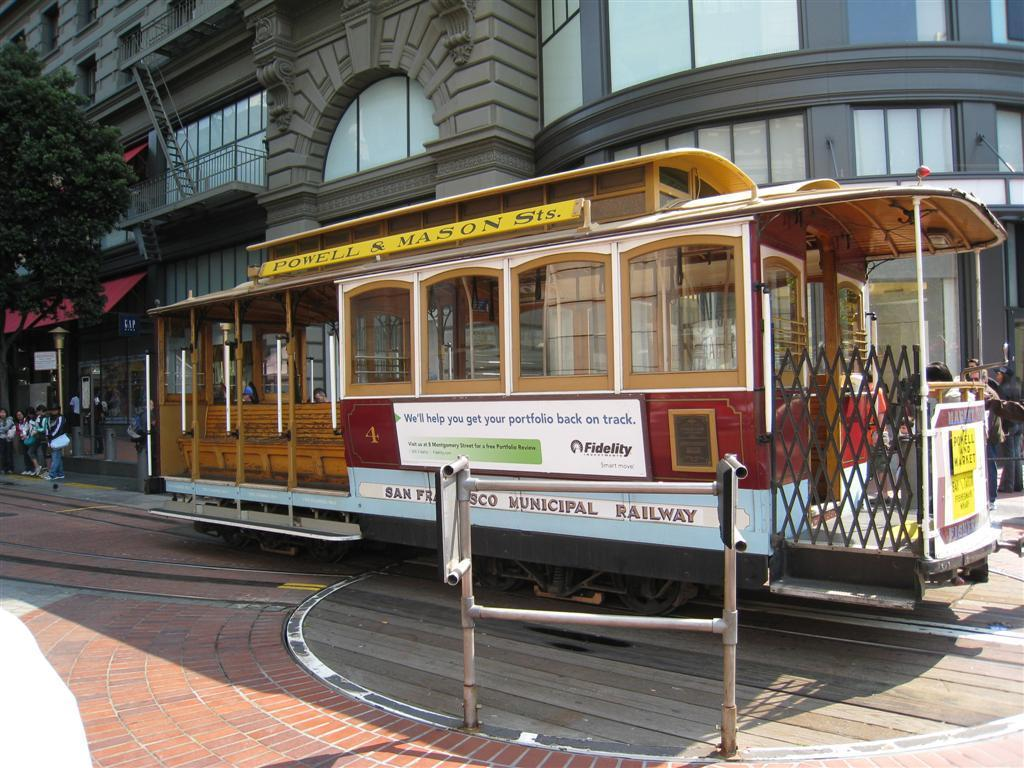What is the main subject of the image? There is a train in the image. What can be seen in the background of the image? There are people standing and a building in the background of the image. Can you describe the top left of the image? There is a tree in the top left of the image. How many cats are sitting on the train in the image? There are no cats present in the image; it features a train with people and a building in the background. 